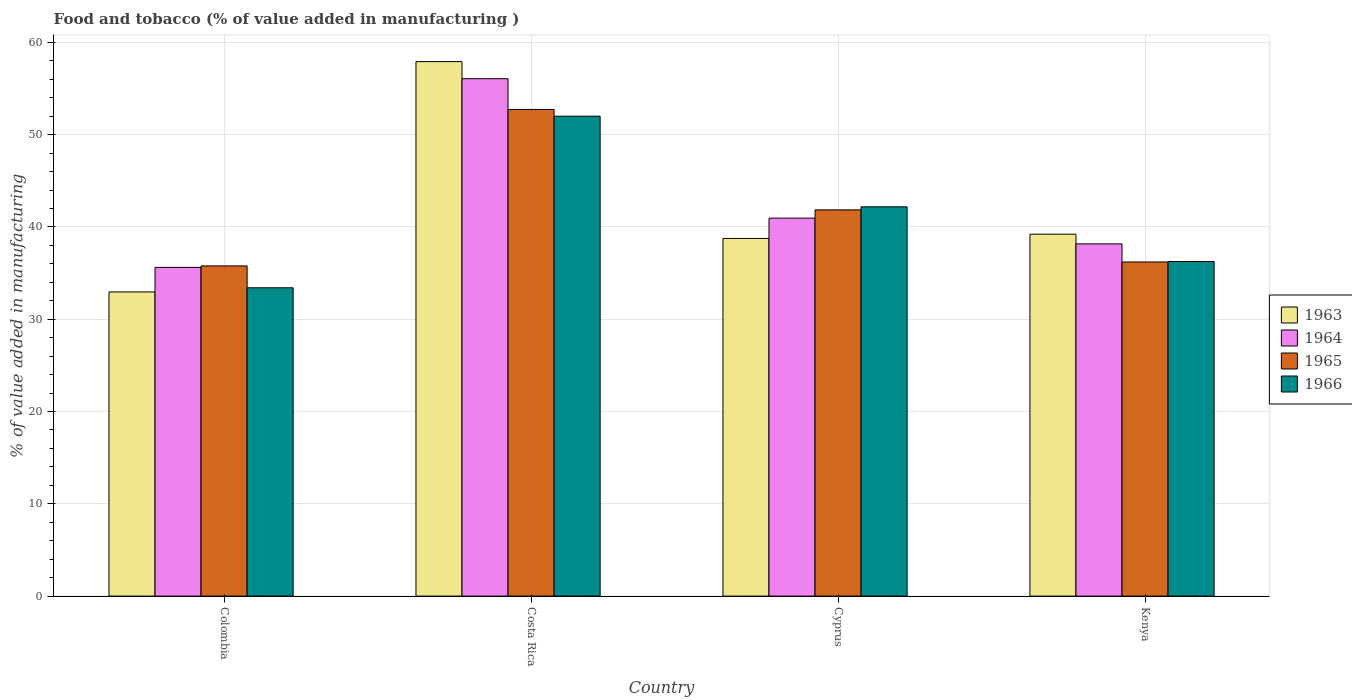How many groups of bars are there?
Offer a very short reply. 4. Are the number of bars on each tick of the X-axis equal?
Provide a succinct answer. Yes. How many bars are there on the 1st tick from the left?
Make the answer very short. 4. What is the label of the 2nd group of bars from the left?
Ensure brevity in your answer.  Costa Rica. What is the value added in manufacturing food and tobacco in 1965 in Kenya?
Make the answer very short. 36.2. Across all countries, what is the maximum value added in manufacturing food and tobacco in 1966?
Offer a terse response. 52. Across all countries, what is the minimum value added in manufacturing food and tobacco in 1966?
Your response must be concise. 33.41. What is the total value added in manufacturing food and tobacco in 1965 in the graph?
Ensure brevity in your answer.  166.57. What is the difference between the value added in manufacturing food and tobacco in 1965 in Colombia and that in Kenya?
Offer a terse response. -0.42. What is the difference between the value added in manufacturing food and tobacco in 1965 in Cyprus and the value added in manufacturing food and tobacco in 1964 in Kenya?
Make the answer very short. 3.69. What is the average value added in manufacturing food and tobacco in 1964 per country?
Give a very brief answer. 42.7. What is the difference between the value added in manufacturing food and tobacco of/in 1965 and value added in manufacturing food and tobacco of/in 1963 in Kenya?
Ensure brevity in your answer.  -3.01. What is the ratio of the value added in manufacturing food and tobacco in 1965 in Cyprus to that in Kenya?
Provide a short and direct response. 1.16. Is the value added in manufacturing food and tobacco in 1964 in Cyprus less than that in Kenya?
Your response must be concise. No. Is the difference between the value added in manufacturing food and tobacco in 1965 in Cyprus and Kenya greater than the difference between the value added in manufacturing food and tobacco in 1963 in Cyprus and Kenya?
Give a very brief answer. Yes. What is the difference between the highest and the second highest value added in manufacturing food and tobacco in 1966?
Offer a terse response. -9.82. What is the difference between the highest and the lowest value added in manufacturing food and tobacco in 1963?
Keep it short and to the point. 24.96. In how many countries, is the value added in manufacturing food and tobacco in 1963 greater than the average value added in manufacturing food and tobacco in 1963 taken over all countries?
Keep it short and to the point. 1. What does the 4th bar from the left in Costa Rica represents?
Your answer should be compact. 1966. What does the 2nd bar from the right in Colombia represents?
Your response must be concise. 1965. Is it the case that in every country, the sum of the value added in manufacturing food and tobacco in 1966 and value added in manufacturing food and tobacco in 1965 is greater than the value added in manufacturing food and tobacco in 1964?
Provide a succinct answer. Yes. How many bars are there?
Offer a very short reply. 16. What is the difference between two consecutive major ticks on the Y-axis?
Your answer should be very brief. 10. Are the values on the major ticks of Y-axis written in scientific E-notation?
Your response must be concise. No. Where does the legend appear in the graph?
Keep it short and to the point. Center right. How are the legend labels stacked?
Give a very brief answer. Vertical. What is the title of the graph?
Provide a succinct answer. Food and tobacco (% of value added in manufacturing ). What is the label or title of the X-axis?
Keep it short and to the point. Country. What is the label or title of the Y-axis?
Your answer should be very brief. % of value added in manufacturing. What is the % of value added in manufacturing in 1963 in Colombia?
Your response must be concise. 32.96. What is the % of value added in manufacturing of 1964 in Colombia?
Make the answer very short. 35.62. What is the % of value added in manufacturing of 1965 in Colombia?
Your response must be concise. 35.78. What is the % of value added in manufacturing of 1966 in Colombia?
Your answer should be compact. 33.41. What is the % of value added in manufacturing in 1963 in Costa Rica?
Give a very brief answer. 57.92. What is the % of value added in manufacturing in 1964 in Costa Rica?
Your answer should be very brief. 56.07. What is the % of value added in manufacturing in 1965 in Costa Rica?
Your answer should be compact. 52.73. What is the % of value added in manufacturing in 1966 in Costa Rica?
Offer a very short reply. 52. What is the % of value added in manufacturing in 1963 in Cyprus?
Make the answer very short. 38.75. What is the % of value added in manufacturing of 1964 in Cyprus?
Ensure brevity in your answer.  40.96. What is the % of value added in manufacturing of 1965 in Cyprus?
Provide a succinct answer. 41.85. What is the % of value added in manufacturing in 1966 in Cyprus?
Ensure brevity in your answer.  42.19. What is the % of value added in manufacturing in 1963 in Kenya?
Keep it short and to the point. 39.22. What is the % of value added in manufacturing in 1964 in Kenya?
Provide a succinct answer. 38.17. What is the % of value added in manufacturing in 1965 in Kenya?
Provide a short and direct response. 36.2. What is the % of value added in manufacturing of 1966 in Kenya?
Your answer should be compact. 36.25. Across all countries, what is the maximum % of value added in manufacturing in 1963?
Provide a succinct answer. 57.92. Across all countries, what is the maximum % of value added in manufacturing in 1964?
Your answer should be very brief. 56.07. Across all countries, what is the maximum % of value added in manufacturing of 1965?
Keep it short and to the point. 52.73. Across all countries, what is the maximum % of value added in manufacturing of 1966?
Your answer should be very brief. 52. Across all countries, what is the minimum % of value added in manufacturing in 1963?
Give a very brief answer. 32.96. Across all countries, what is the minimum % of value added in manufacturing of 1964?
Keep it short and to the point. 35.62. Across all countries, what is the minimum % of value added in manufacturing in 1965?
Offer a terse response. 35.78. Across all countries, what is the minimum % of value added in manufacturing in 1966?
Your answer should be compact. 33.41. What is the total % of value added in manufacturing of 1963 in the graph?
Offer a terse response. 168.85. What is the total % of value added in manufacturing of 1964 in the graph?
Ensure brevity in your answer.  170.81. What is the total % of value added in manufacturing of 1965 in the graph?
Keep it short and to the point. 166.57. What is the total % of value added in manufacturing of 1966 in the graph?
Make the answer very short. 163.86. What is the difference between the % of value added in manufacturing of 1963 in Colombia and that in Costa Rica?
Make the answer very short. -24.96. What is the difference between the % of value added in manufacturing in 1964 in Colombia and that in Costa Rica?
Your answer should be compact. -20.45. What is the difference between the % of value added in manufacturing of 1965 in Colombia and that in Costa Rica?
Give a very brief answer. -16.95. What is the difference between the % of value added in manufacturing of 1966 in Colombia and that in Costa Rica?
Ensure brevity in your answer.  -18.59. What is the difference between the % of value added in manufacturing of 1963 in Colombia and that in Cyprus?
Your answer should be very brief. -5.79. What is the difference between the % of value added in manufacturing in 1964 in Colombia and that in Cyprus?
Your response must be concise. -5.34. What is the difference between the % of value added in manufacturing in 1965 in Colombia and that in Cyprus?
Provide a short and direct response. -6.07. What is the difference between the % of value added in manufacturing of 1966 in Colombia and that in Cyprus?
Your response must be concise. -8.78. What is the difference between the % of value added in manufacturing in 1963 in Colombia and that in Kenya?
Provide a short and direct response. -6.26. What is the difference between the % of value added in manufacturing in 1964 in Colombia and that in Kenya?
Your answer should be compact. -2.55. What is the difference between the % of value added in manufacturing of 1965 in Colombia and that in Kenya?
Offer a terse response. -0.42. What is the difference between the % of value added in manufacturing in 1966 in Colombia and that in Kenya?
Offer a very short reply. -2.84. What is the difference between the % of value added in manufacturing in 1963 in Costa Rica and that in Cyprus?
Your answer should be compact. 19.17. What is the difference between the % of value added in manufacturing of 1964 in Costa Rica and that in Cyprus?
Your answer should be compact. 15.11. What is the difference between the % of value added in manufacturing of 1965 in Costa Rica and that in Cyprus?
Provide a succinct answer. 10.88. What is the difference between the % of value added in manufacturing of 1966 in Costa Rica and that in Cyprus?
Keep it short and to the point. 9.82. What is the difference between the % of value added in manufacturing in 1963 in Costa Rica and that in Kenya?
Make the answer very short. 18.7. What is the difference between the % of value added in manufacturing of 1964 in Costa Rica and that in Kenya?
Provide a short and direct response. 17.9. What is the difference between the % of value added in manufacturing in 1965 in Costa Rica and that in Kenya?
Ensure brevity in your answer.  16.53. What is the difference between the % of value added in manufacturing in 1966 in Costa Rica and that in Kenya?
Your answer should be very brief. 15.75. What is the difference between the % of value added in manufacturing of 1963 in Cyprus and that in Kenya?
Your answer should be compact. -0.46. What is the difference between the % of value added in manufacturing in 1964 in Cyprus and that in Kenya?
Offer a terse response. 2.79. What is the difference between the % of value added in manufacturing of 1965 in Cyprus and that in Kenya?
Provide a succinct answer. 5.65. What is the difference between the % of value added in manufacturing in 1966 in Cyprus and that in Kenya?
Make the answer very short. 5.93. What is the difference between the % of value added in manufacturing of 1963 in Colombia and the % of value added in manufacturing of 1964 in Costa Rica?
Provide a short and direct response. -23.11. What is the difference between the % of value added in manufacturing of 1963 in Colombia and the % of value added in manufacturing of 1965 in Costa Rica?
Provide a succinct answer. -19.77. What is the difference between the % of value added in manufacturing in 1963 in Colombia and the % of value added in manufacturing in 1966 in Costa Rica?
Your answer should be compact. -19.04. What is the difference between the % of value added in manufacturing in 1964 in Colombia and the % of value added in manufacturing in 1965 in Costa Rica?
Give a very brief answer. -17.11. What is the difference between the % of value added in manufacturing in 1964 in Colombia and the % of value added in manufacturing in 1966 in Costa Rica?
Make the answer very short. -16.38. What is the difference between the % of value added in manufacturing in 1965 in Colombia and the % of value added in manufacturing in 1966 in Costa Rica?
Give a very brief answer. -16.22. What is the difference between the % of value added in manufacturing of 1963 in Colombia and the % of value added in manufacturing of 1964 in Cyprus?
Make the answer very short. -8. What is the difference between the % of value added in manufacturing of 1963 in Colombia and the % of value added in manufacturing of 1965 in Cyprus?
Provide a succinct answer. -8.89. What is the difference between the % of value added in manufacturing in 1963 in Colombia and the % of value added in manufacturing in 1966 in Cyprus?
Your answer should be compact. -9.23. What is the difference between the % of value added in manufacturing of 1964 in Colombia and the % of value added in manufacturing of 1965 in Cyprus?
Your response must be concise. -6.23. What is the difference between the % of value added in manufacturing of 1964 in Colombia and the % of value added in manufacturing of 1966 in Cyprus?
Make the answer very short. -6.57. What is the difference between the % of value added in manufacturing in 1965 in Colombia and the % of value added in manufacturing in 1966 in Cyprus?
Ensure brevity in your answer.  -6.41. What is the difference between the % of value added in manufacturing in 1963 in Colombia and the % of value added in manufacturing in 1964 in Kenya?
Give a very brief answer. -5.21. What is the difference between the % of value added in manufacturing in 1963 in Colombia and the % of value added in manufacturing in 1965 in Kenya?
Your response must be concise. -3.24. What is the difference between the % of value added in manufacturing of 1963 in Colombia and the % of value added in manufacturing of 1966 in Kenya?
Offer a very short reply. -3.29. What is the difference between the % of value added in manufacturing of 1964 in Colombia and the % of value added in manufacturing of 1965 in Kenya?
Offer a terse response. -0.58. What is the difference between the % of value added in manufacturing in 1964 in Colombia and the % of value added in manufacturing in 1966 in Kenya?
Keep it short and to the point. -0.63. What is the difference between the % of value added in manufacturing in 1965 in Colombia and the % of value added in manufacturing in 1966 in Kenya?
Keep it short and to the point. -0.47. What is the difference between the % of value added in manufacturing in 1963 in Costa Rica and the % of value added in manufacturing in 1964 in Cyprus?
Your answer should be very brief. 16.96. What is the difference between the % of value added in manufacturing of 1963 in Costa Rica and the % of value added in manufacturing of 1965 in Cyprus?
Offer a very short reply. 16.07. What is the difference between the % of value added in manufacturing of 1963 in Costa Rica and the % of value added in manufacturing of 1966 in Cyprus?
Offer a terse response. 15.73. What is the difference between the % of value added in manufacturing of 1964 in Costa Rica and the % of value added in manufacturing of 1965 in Cyprus?
Provide a short and direct response. 14.21. What is the difference between the % of value added in manufacturing in 1964 in Costa Rica and the % of value added in manufacturing in 1966 in Cyprus?
Provide a short and direct response. 13.88. What is the difference between the % of value added in manufacturing in 1965 in Costa Rica and the % of value added in manufacturing in 1966 in Cyprus?
Keep it short and to the point. 10.55. What is the difference between the % of value added in manufacturing of 1963 in Costa Rica and the % of value added in manufacturing of 1964 in Kenya?
Your answer should be compact. 19.75. What is the difference between the % of value added in manufacturing of 1963 in Costa Rica and the % of value added in manufacturing of 1965 in Kenya?
Make the answer very short. 21.72. What is the difference between the % of value added in manufacturing in 1963 in Costa Rica and the % of value added in manufacturing in 1966 in Kenya?
Your answer should be very brief. 21.67. What is the difference between the % of value added in manufacturing in 1964 in Costa Rica and the % of value added in manufacturing in 1965 in Kenya?
Give a very brief answer. 19.86. What is the difference between the % of value added in manufacturing in 1964 in Costa Rica and the % of value added in manufacturing in 1966 in Kenya?
Your response must be concise. 19.81. What is the difference between the % of value added in manufacturing of 1965 in Costa Rica and the % of value added in manufacturing of 1966 in Kenya?
Your answer should be compact. 16.48. What is the difference between the % of value added in manufacturing in 1963 in Cyprus and the % of value added in manufacturing in 1964 in Kenya?
Provide a succinct answer. 0.59. What is the difference between the % of value added in manufacturing of 1963 in Cyprus and the % of value added in manufacturing of 1965 in Kenya?
Ensure brevity in your answer.  2.55. What is the difference between the % of value added in manufacturing of 1963 in Cyprus and the % of value added in manufacturing of 1966 in Kenya?
Offer a terse response. 2.5. What is the difference between the % of value added in manufacturing of 1964 in Cyprus and the % of value added in manufacturing of 1965 in Kenya?
Your answer should be compact. 4.75. What is the difference between the % of value added in manufacturing of 1964 in Cyprus and the % of value added in manufacturing of 1966 in Kenya?
Your response must be concise. 4.7. What is the difference between the % of value added in manufacturing of 1965 in Cyprus and the % of value added in manufacturing of 1966 in Kenya?
Provide a succinct answer. 5.6. What is the average % of value added in manufacturing in 1963 per country?
Make the answer very short. 42.21. What is the average % of value added in manufacturing in 1964 per country?
Make the answer very short. 42.7. What is the average % of value added in manufacturing of 1965 per country?
Keep it short and to the point. 41.64. What is the average % of value added in manufacturing of 1966 per country?
Give a very brief answer. 40.96. What is the difference between the % of value added in manufacturing of 1963 and % of value added in manufacturing of 1964 in Colombia?
Your answer should be compact. -2.66. What is the difference between the % of value added in manufacturing in 1963 and % of value added in manufacturing in 1965 in Colombia?
Provide a short and direct response. -2.82. What is the difference between the % of value added in manufacturing of 1963 and % of value added in manufacturing of 1966 in Colombia?
Provide a succinct answer. -0.45. What is the difference between the % of value added in manufacturing of 1964 and % of value added in manufacturing of 1965 in Colombia?
Offer a very short reply. -0.16. What is the difference between the % of value added in manufacturing of 1964 and % of value added in manufacturing of 1966 in Colombia?
Keep it short and to the point. 2.21. What is the difference between the % of value added in manufacturing of 1965 and % of value added in manufacturing of 1966 in Colombia?
Provide a short and direct response. 2.37. What is the difference between the % of value added in manufacturing in 1963 and % of value added in manufacturing in 1964 in Costa Rica?
Offer a very short reply. 1.85. What is the difference between the % of value added in manufacturing in 1963 and % of value added in manufacturing in 1965 in Costa Rica?
Your response must be concise. 5.19. What is the difference between the % of value added in manufacturing in 1963 and % of value added in manufacturing in 1966 in Costa Rica?
Keep it short and to the point. 5.92. What is the difference between the % of value added in manufacturing in 1964 and % of value added in manufacturing in 1965 in Costa Rica?
Your response must be concise. 3.33. What is the difference between the % of value added in manufacturing of 1964 and % of value added in manufacturing of 1966 in Costa Rica?
Give a very brief answer. 4.06. What is the difference between the % of value added in manufacturing in 1965 and % of value added in manufacturing in 1966 in Costa Rica?
Give a very brief answer. 0.73. What is the difference between the % of value added in manufacturing of 1963 and % of value added in manufacturing of 1964 in Cyprus?
Give a very brief answer. -2.2. What is the difference between the % of value added in manufacturing of 1963 and % of value added in manufacturing of 1965 in Cyprus?
Keep it short and to the point. -3.1. What is the difference between the % of value added in manufacturing of 1963 and % of value added in manufacturing of 1966 in Cyprus?
Offer a very short reply. -3.43. What is the difference between the % of value added in manufacturing in 1964 and % of value added in manufacturing in 1965 in Cyprus?
Give a very brief answer. -0.9. What is the difference between the % of value added in manufacturing of 1964 and % of value added in manufacturing of 1966 in Cyprus?
Offer a terse response. -1.23. What is the difference between the % of value added in manufacturing of 1963 and % of value added in manufacturing of 1964 in Kenya?
Your answer should be compact. 1.05. What is the difference between the % of value added in manufacturing of 1963 and % of value added in manufacturing of 1965 in Kenya?
Your answer should be compact. 3.01. What is the difference between the % of value added in manufacturing in 1963 and % of value added in manufacturing in 1966 in Kenya?
Ensure brevity in your answer.  2.96. What is the difference between the % of value added in manufacturing of 1964 and % of value added in manufacturing of 1965 in Kenya?
Give a very brief answer. 1.96. What is the difference between the % of value added in manufacturing of 1964 and % of value added in manufacturing of 1966 in Kenya?
Make the answer very short. 1.91. What is the difference between the % of value added in manufacturing of 1965 and % of value added in manufacturing of 1966 in Kenya?
Ensure brevity in your answer.  -0.05. What is the ratio of the % of value added in manufacturing of 1963 in Colombia to that in Costa Rica?
Your answer should be very brief. 0.57. What is the ratio of the % of value added in manufacturing in 1964 in Colombia to that in Costa Rica?
Provide a short and direct response. 0.64. What is the ratio of the % of value added in manufacturing in 1965 in Colombia to that in Costa Rica?
Make the answer very short. 0.68. What is the ratio of the % of value added in manufacturing of 1966 in Colombia to that in Costa Rica?
Your answer should be very brief. 0.64. What is the ratio of the % of value added in manufacturing of 1963 in Colombia to that in Cyprus?
Provide a short and direct response. 0.85. What is the ratio of the % of value added in manufacturing in 1964 in Colombia to that in Cyprus?
Ensure brevity in your answer.  0.87. What is the ratio of the % of value added in manufacturing of 1965 in Colombia to that in Cyprus?
Your answer should be very brief. 0.85. What is the ratio of the % of value added in manufacturing in 1966 in Colombia to that in Cyprus?
Your response must be concise. 0.79. What is the ratio of the % of value added in manufacturing in 1963 in Colombia to that in Kenya?
Ensure brevity in your answer.  0.84. What is the ratio of the % of value added in manufacturing in 1964 in Colombia to that in Kenya?
Your answer should be compact. 0.93. What is the ratio of the % of value added in manufacturing in 1965 in Colombia to that in Kenya?
Your answer should be very brief. 0.99. What is the ratio of the % of value added in manufacturing in 1966 in Colombia to that in Kenya?
Give a very brief answer. 0.92. What is the ratio of the % of value added in manufacturing of 1963 in Costa Rica to that in Cyprus?
Provide a short and direct response. 1.49. What is the ratio of the % of value added in manufacturing of 1964 in Costa Rica to that in Cyprus?
Give a very brief answer. 1.37. What is the ratio of the % of value added in manufacturing of 1965 in Costa Rica to that in Cyprus?
Your response must be concise. 1.26. What is the ratio of the % of value added in manufacturing in 1966 in Costa Rica to that in Cyprus?
Offer a very short reply. 1.23. What is the ratio of the % of value added in manufacturing of 1963 in Costa Rica to that in Kenya?
Provide a short and direct response. 1.48. What is the ratio of the % of value added in manufacturing in 1964 in Costa Rica to that in Kenya?
Offer a very short reply. 1.47. What is the ratio of the % of value added in manufacturing in 1965 in Costa Rica to that in Kenya?
Your response must be concise. 1.46. What is the ratio of the % of value added in manufacturing in 1966 in Costa Rica to that in Kenya?
Ensure brevity in your answer.  1.43. What is the ratio of the % of value added in manufacturing in 1963 in Cyprus to that in Kenya?
Make the answer very short. 0.99. What is the ratio of the % of value added in manufacturing in 1964 in Cyprus to that in Kenya?
Provide a short and direct response. 1.07. What is the ratio of the % of value added in manufacturing of 1965 in Cyprus to that in Kenya?
Give a very brief answer. 1.16. What is the ratio of the % of value added in manufacturing of 1966 in Cyprus to that in Kenya?
Give a very brief answer. 1.16. What is the difference between the highest and the second highest % of value added in manufacturing of 1963?
Provide a succinct answer. 18.7. What is the difference between the highest and the second highest % of value added in manufacturing in 1964?
Your response must be concise. 15.11. What is the difference between the highest and the second highest % of value added in manufacturing in 1965?
Keep it short and to the point. 10.88. What is the difference between the highest and the second highest % of value added in manufacturing in 1966?
Give a very brief answer. 9.82. What is the difference between the highest and the lowest % of value added in manufacturing in 1963?
Provide a succinct answer. 24.96. What is the difference between the highest and the lowest % of value added in manufacturing in 1964?
Provide a short and direct response. 20.45. What is the difference between the highest and the lowest % of value added in manufacturing of 1965?
Provide a short and direct response. 16.95. What is the difference between the highest and the lowest % of value added in manufacturing in 1966?
Offer a very short reply. 18.59. 